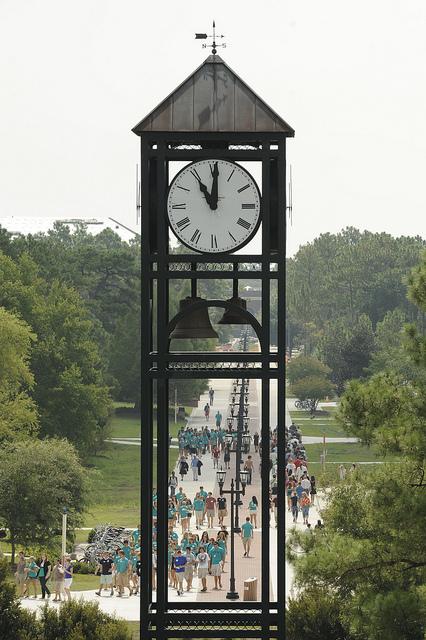What are the bells for?
Keep it brief. Time. What time is it?
Quick response, please. 11:00. How many people are in the street?
Keep it brief. 50. 